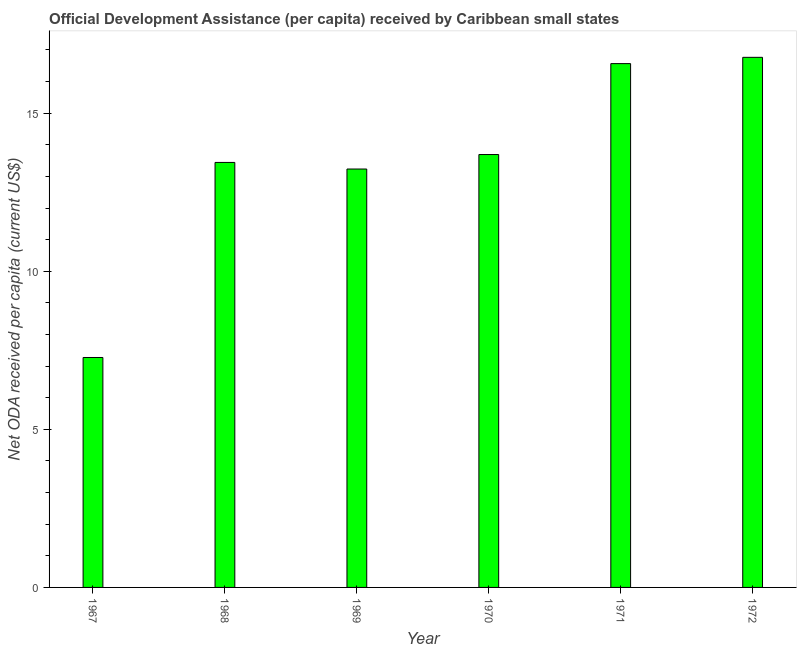Does the graph contain grids?
Keep it short and to the point. No. What is the title of the graph?
Offer a terse response. Official Development Assistance (per capita) received by Caribbean small states. What is the label or title of the Y-axis?
Keep it short and to the point. Net ODA received per capita (current US$). What is the net oda received per capita in 1969?
Ensure brevity in your answer.  13.23. Across all years, what is the maximum net oda received per capita?
Offer a very short reply. 16.77. Across all years, what is the minimum net oda received per capita?
Make the answer very short. 7.27. In which year was the net oda received per capita minimum?
Offer a very short reply. 1967. What is the sum of the net oda received per capita?
Make the answer very short. 80.97. What is the difference between the net oda received per capita in 1968 and 1972?
Give a very brief answer. -3.32. What is the average net oda received per capita per year?
Offer a terse response. 13.49. What is the median net oda received per capita?
Your answer should be compact. 13.57. In how many years, is the net oda received per capita greater than 10 US$?
Make the answer very short. 5. Do a majority of the years between 1968 and 1970 (inclusive) have net oda received per capita greater than 2 US$?
Your answer should be compact. Yes. What is the ratio of the net oda received per capita in 1969 to that in 1972?
Provide a short and direct response. 0.79. What is the difference between the highest and the second highest net oda received per capita?
Offer a very short reply. 0.2. What is the difference between the highest and the lowest net oda received per capita?
Provide a succinct answer. 9.49. How many bars are there?
Offer a very short reply. 6. How many years are there in the graph?
Your response must be concise. 6. What is the difference between two consecutive major ticks on the Y-axis?
Provide a short and direct response. 5. What is the Net ODA received per capita (current US$) of 1967?
Ensure brevity in your answer.  7.27. What is the Net ODA received per capita (current US$) of 1968?
Your answer should be very brief. 13.44. What is the Net ODA received per capita (current US$) of 1969?
Offer a very short reply. 13.23. What is the Net ODA received per capita (current US$) in 1970?
Your response must be concise. 13.69. What is the Net ODA received per capita (current US$) of 1971?
Offer a terse response. 16.57. What is the Net ODA received per capita (current US$) in 1972?
Offer a very short reply. 16.77. What is the difference between the Net ODA received per capita (current US$) in 1967 and 1968?
Your response must be concise. -6.17. What is the difference between the Net ODA received per capita (current US$) in 1967 and 1969?
Offer a very short reply. -5.96. What is the difference between the Net ODA received per capita (current US$) in 1967 and 1970?
Keep it short and to the point. -6.42. What is the difference between the Net ODA received per capita (current US$) in 1967 and 1971?
Give a very brief answer. -9.29. What is the difference between the Net ODA received per capita (current US$) in 1967 and 1972?
Provide a succinct answer. -9.49. What is the difference between the Net ODA received per capita (current US$) in 1968 and 1969?
Give a very brief answer. 0.21. What is the difference between the Net ODA received per capita (current US$) in 1968 and 1970?
Keep it short and to the point. -0.25. What is the difference between the Net ODA received per capita (current US$) in 1968 and 1971?
Ensure brevity in your answer.  -3.13. What is the difference between the Net ODA received per capita (current US$) in 1968 and 1972?
Ensure brevity in your answer.  -3.32. What is the difference between the Net ODA received per capita (current US$) in 1969 and 1970?
Your response must be concise. -0.46. What is the difference between the Net ODA received per capita (current US$) in 1969 and 1971?
Offer a very short reply. -3.33. What is the difference between the Net ODA received per capita (current US$) in 1969 and 1972?
Give a very brief answer. -3.53. What is the difference between the Net ODA received per capita (current US$) in 1970 and 1971?
Make the answer very short. -2.88. What is the difference between the Net ODA received per capita (current US$) in 1970 and 1972?
Your answer should be compact. -3.07. What is the difference between the Net ODA received per capita (current US$) in 1971 and 1972?
Your answer should be very brief. -0.2. What is the ratio of the Net ODA received per capita (current US$) in 1967 to that in 1968?
Provide a short and direct response. 0.54. What is the ratio of the Net ODA received per capita (current US$) in 1967 to that in 1969?
Your response must be concise. 0.55. What is the ratio of the Net ODA received per capita (current US$) in 1967 to that in 1970?
Give a very brief answer. 0.53. What is the ratio of the Net ODA received per capita (current US$) in 1967 to that in 1971?
Give a very brief answer. 0.44. What is the ratio of the Net ODA received per capita (current US$) in 1967 to that in 1972?
Your response must be concise. 0.43. What is the ratio of the Net ODA received per capita (current US$) in 1968 to that in 1969?
Ensure brevity in your answer.  1.02. What is the ratio of the Net ODA received per capita (current US$) in 1968 to that in 1970?
Your answer should be compact. 0.98. What is the ratio of the Net ODA received per capita (current US$) in 1968 to that in 1971?
Keep it short and to the point. 0.81. What is the ratio of the Net ODA received per capita (current US$) in 1968 to that in 1972?
Your response must be concise. 0.8. What is the ratio of the Net ODA received per capita (current US$) in 1969 to that in 1970?
Give a very brief answer. 0.97. What is the ratio of the Net ODA received per capita (current US$) in 1969 to that in 1971?
Provide a short and direct response. 0.8. What is the ratio of the Net ODA received per capita (current US$) in 1969 to that in 1972?
Provide a short and direct response. 0.79. What is the ratio of the Net ODA received per capita (current US$) in 1970 to that in 1971?
Keep it short and to the point. 0.83. What is the ratio of the Net ODA received per capita (current US$) in 1970 to that in 1972?
Offer a terse response. 0.82. 